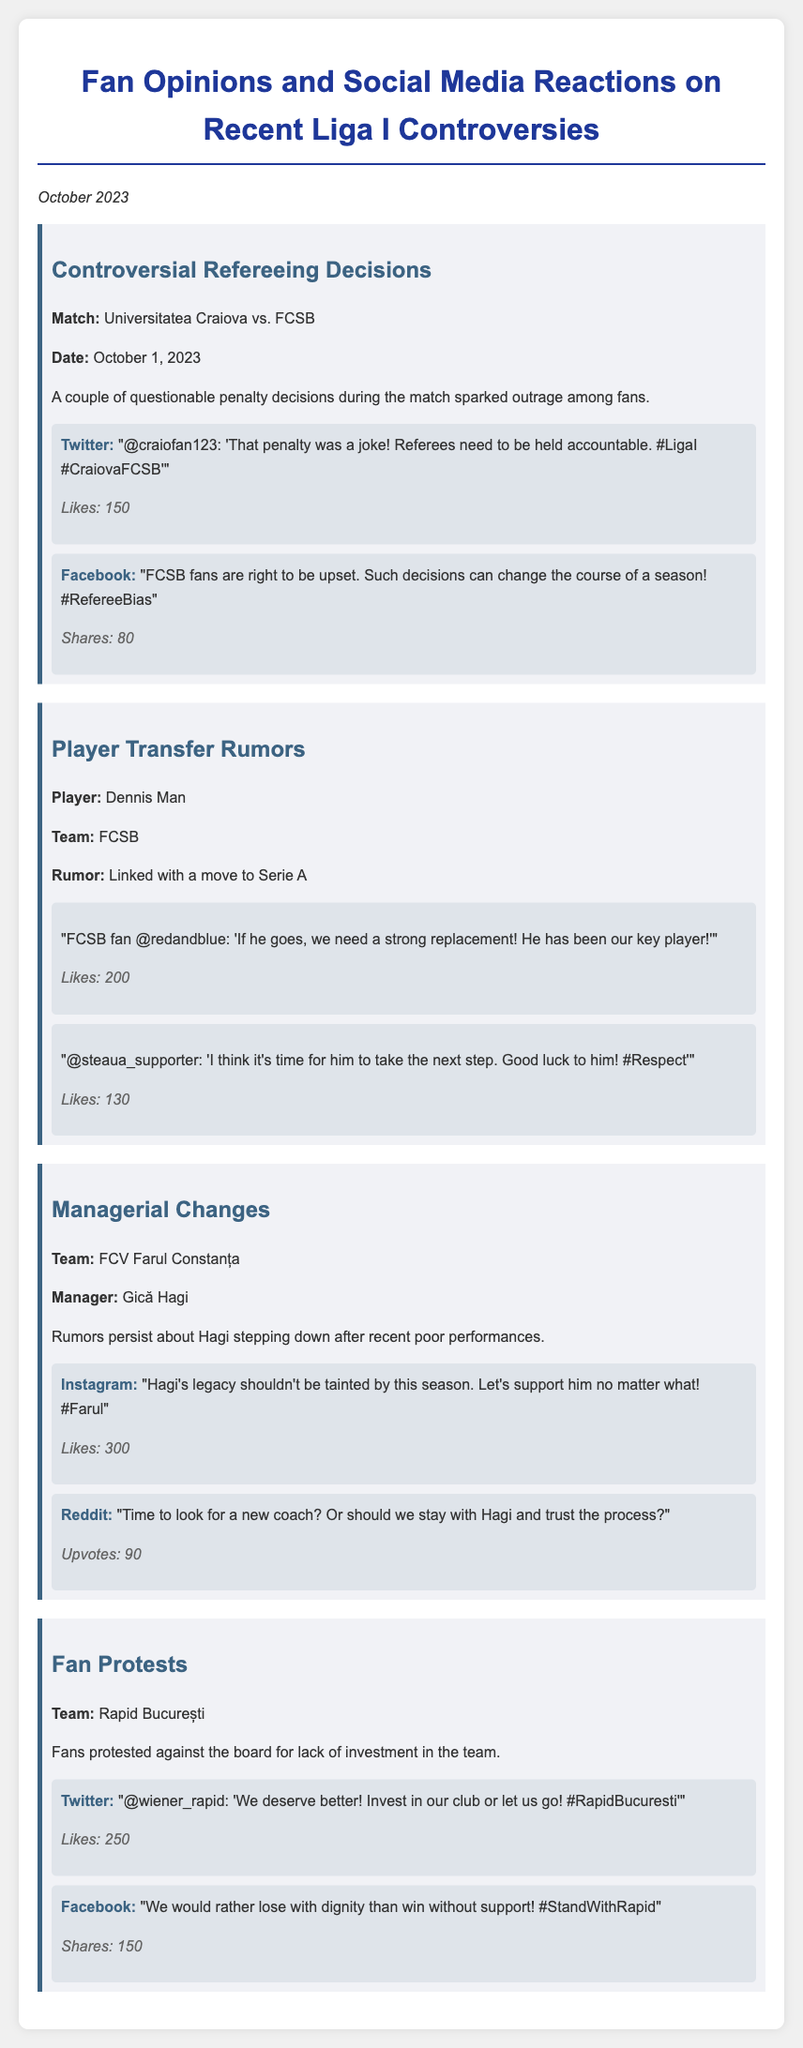What was the date of the Universitatea Craiova vs. FCSB match? The date of the match between Universitatea Craiova and FCSB is mentioned in the document as October 1, 2023.
Answer: October 1, 2023 What was the controversy discussed related to the match between Universitatea Craiova and FCSB? The controversy discussed was about questionable penalty decisions during the match that sparked outrage among fans.
Answer: Questionable penalty decisions Which player is rumored to be linked with a move to Serie A? The player linked with a move to Serie A is specifically named in the document.
Answer: Dennis Man What social media platform had a reaction saying "Hagi's legacy shouldn't be tainted by this season"? The reaction comes from Instagram, as identified by the mentioned platform in the document.
Answer: Instagram What was the primary reason for the protests by Rapid București fans? The protests were against the board for a specific reason, which is mentioned in the document.
Answer: Lack of investment in the team What is Gică Hagi's association with FCV Farul Constanța? The document states that Gică Hagi is the manager of FCV Farul Constanța.
Answer: Manager How many likes did the Twitter reaction from '@craiofan123' receive? The number of likes is clearly indicated under the reaction in the document.
Answer: 150 What reaction did FCSB fans have regarding Dennis Man's rumored transfer? The document includes a sentiment shared by an FCSB fan concerning the potential transfer of Dennis Man.
Answer: Strong replacement needed What sentiment did Rapid București fans express in their social media reactions? The sentiment expressed indicates a desire for better investment in the club or to be let go, as outlined in the document.
Answer: We deserve better! 